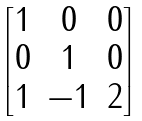Convert formula to latex. <formula><loc_0><loc_0><loc_500><loc_500>\begin{bmatrix} 1 & 0 & 0 \\ 0 & 1 & 0 \\ 1 & - 1 & 2 \end{bmatrix}</formula> 